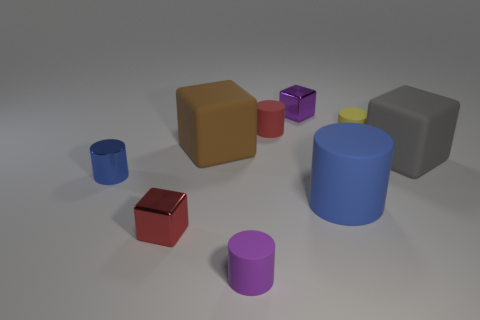There is a tiny blue metallic cylinder that is to the left of the red object behind the red metal block; are there any red cubes in front of it?
Provide a succinct answer. Yes. What number of big brown spheres are the same material as the small purple cylinder?
Offer a terse response. 0. Do the matte block to the left of the red rubber thing and the shiny thing behind the gray object have the same size?
Keep it short and to the point. No. There is a small block that is behind the blue thing on the right side of the metallic cube that is in front of the small purple cube; what is its color?
Your response must be concise. Purple. Is there a purple metallic object of the same shape as the red metallic object?
Offer a very short reply. Yes. Are there the same number of big blue matte cylinders on the left side of the big brown matte object and metallic cylinders that are in front of the large cylinder?
Offer a terse response. Yes. There is a blue thing that is on the left side of the big brown object; is it the same shape as the tiny red rubber thing?
Offer a terse response. Yes. Is the brown rubber object the same shape as the small red metal thing?
Offer a very short reply. Yes. How many matte objects are either big brown objects or red cubes?
Offer a very short reply. 1. What material is the other cylinder that is the same color as the large cylinder?
Provide a short and direct response. Metal. 